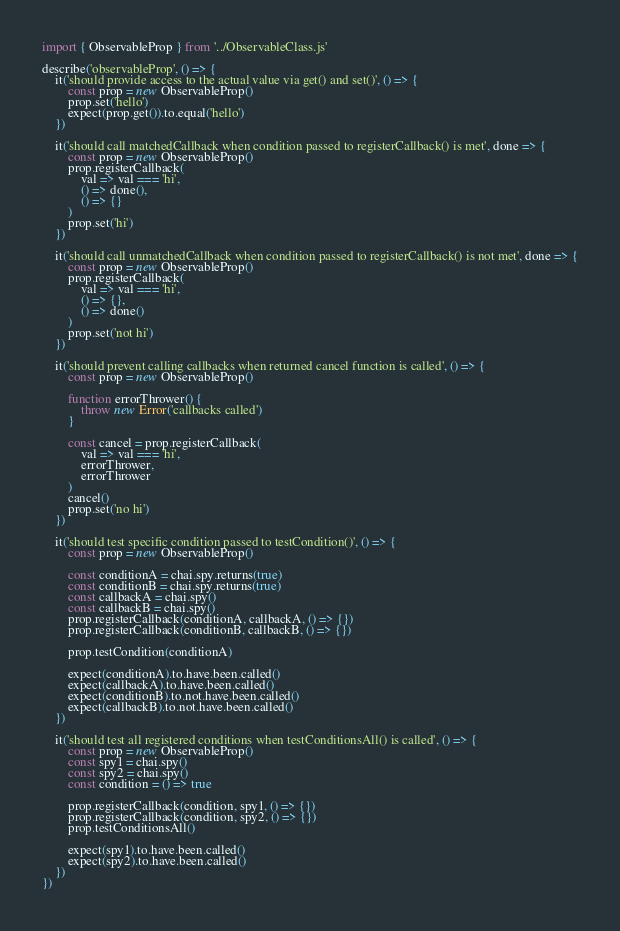Convert code to text. <code><loc_0><loc_0><loc_500><loc_500><_JavaScript_>import { ObservableProp } from '../ObservableClass.js'

describe('observableProp', () => {
    it('should provide access to the actual value via get() and set()', () => {
        const prop = new ObservableProp()
        prop.set('hello')
        expect(prop.get()).to.equal('hello')
    })

    it('should call matchedCallback when condition passed to registerCallback() is met', done => {
        const prop = new ObservableProp()
        prop.registerCallback(
            val => val === 'hi',
            () => done(),
            () => {}
        )
        prop.set('hi')
    })

    it('should call unmatchedCallback when condition passed to registerCallback() is not met', done => {
        const prop = new ObservableProp()
        prop.registerCallback(
            val => val === 'hi',
            () => {},
            () => done()
        )
        prop.set('not hi')
    })

    it('should prevent calling callbacks when returned cancel function is called', () => {
        const prop = new ObservableProp()

        function errorThrower() {
            throw new Error('callbacks called')
        }

        const cancel = prop.registerCallback(
            val => val === 'hi',
            errorThrower,
            errorThrower
        )
        cancel()
        prop.set('no hi')
    })

    it('should test specific condition passed to testCondition()', () => {
        const prop = new ObservableProp()

        const conditionA = chai.spy.returns(true)
        const conditionB = chai.spy.returns(true)
        const callbackA = chai.spy()
        const callbackB = chai.spy()
        prop.registerCallback(conditionA, callbackA, () => {})
        prop.registerCallback(conditionB, callbackB, () => {})

        prop.testCondition(conditionA)

        expect(conditionA).to.have.been.called()
        expect(callbackA).to.have.been.called()
        expect(conditionB).to.not.have.been.called()
        expect(callbackB).to.not.have.been.called()
    })

    it('should test all registered conditions when testConditionsAll() is called', () => {
        const prop = new ObservableProp()
        const spy1 = chai.spy()
        const spy2 = chai.spy()
        const condition = () => true

        prop.registerCallback(condition, spy1, () => {})
        prop.registerCallback(condition, spy2, () => {})
        prop.testConditionsAll()
        
        expect(spy1).to.have.been.called()
        expect(spy2).to.have.been.called()
    })
})</code> 